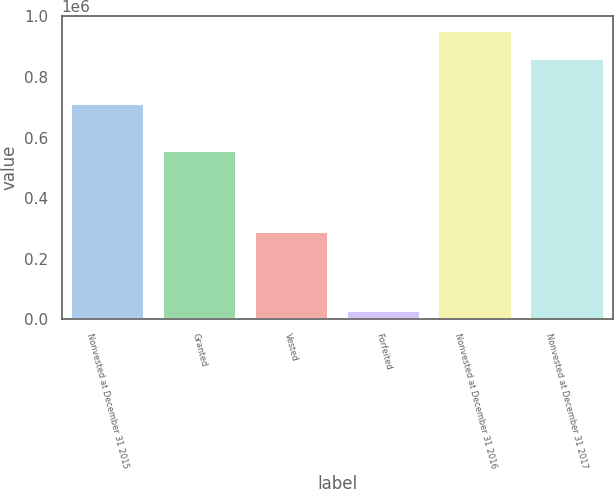<chart> <loc_0><loc_0><loc_500><loc_500><bar_chart><fcel>Nonvested at December 31 2015<fcel>Granted<fcel>Vested<fcel>Forfeited<fcel>Nonvested at December 31 2016<fcel>Nonvested at December 31 2017<nl><fcel>709275<fcel>555730<fcel>287233<fcel>25100<fcel>952672<fcel>858996<nl></chart> 